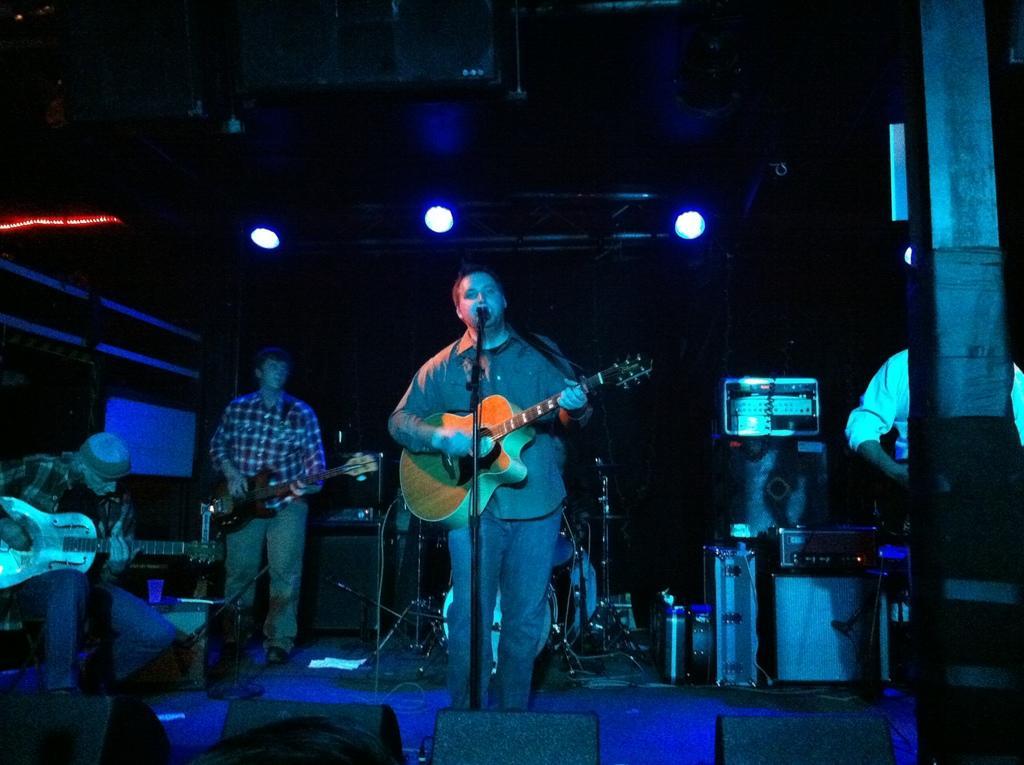How would you summarize this image in a sentence or two? This image is taken in a room. There are four people in this image. In the left side of the image a man is sitting and playing a guitar. In the right side of the image a man is standing. In the middle of the image two men are standing and holding the guitars and playing a music and singing in a mic. At the top of the image there were lights. 